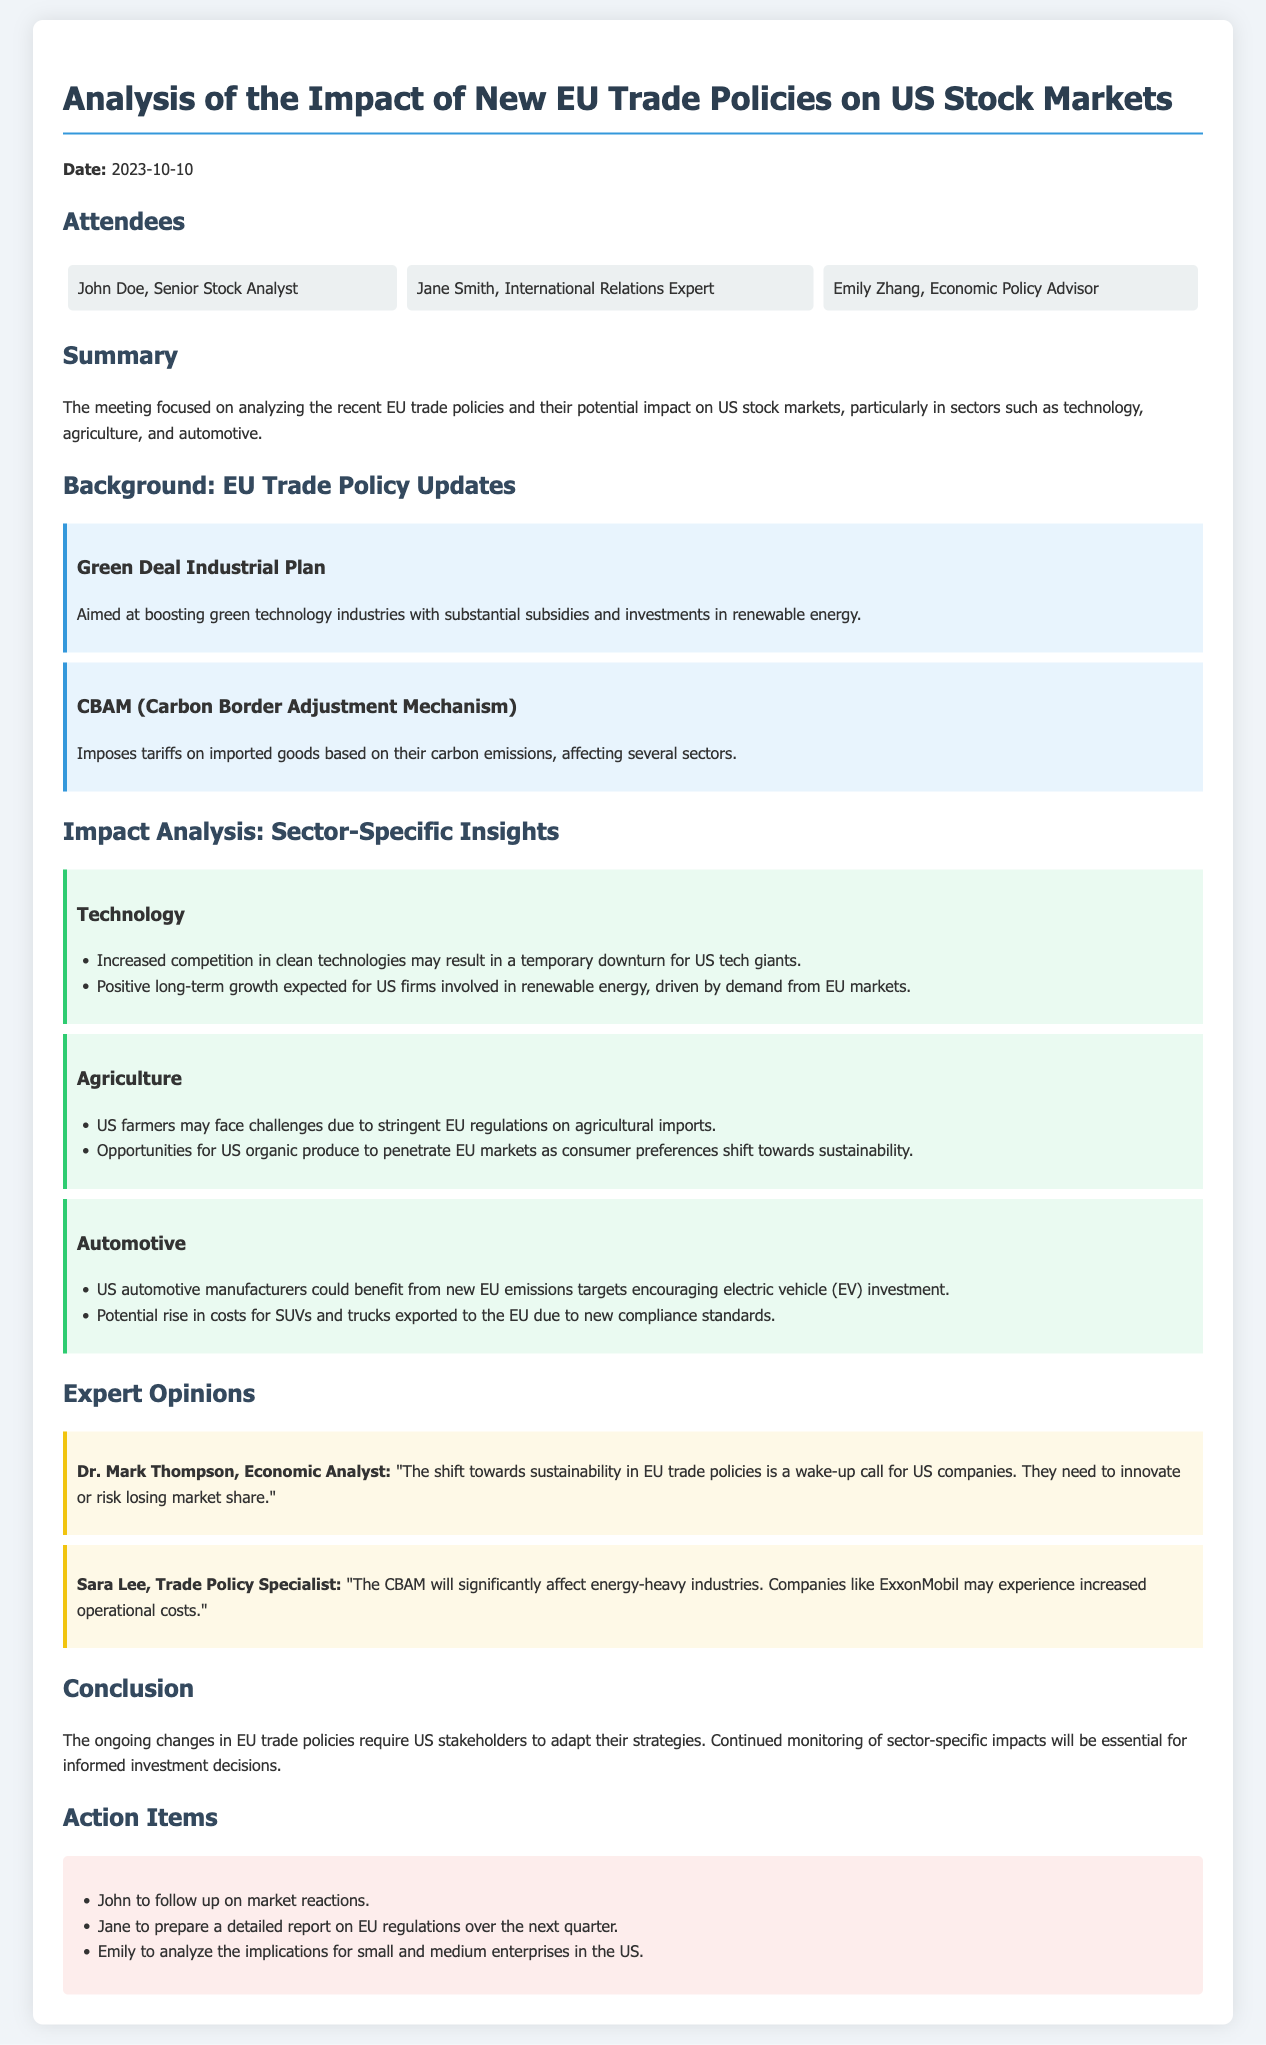What was the date of the meeting? The date of the meeting is mentioned at the beginning of the document.
Answer: 2023-10-10 Who is the Economic Policy Advisor present at the meeting? The document lists attendees, including their titles.
Answer: Emily Zhang What is the focus of the meeting? The summary section outlines the main focus of the meeting.
Answer: Analyzing the recent EU trade policies What are the two major EU trade policies discussed? The background section specifies the trade policies that are analyzed.
Answer: Green Deal Industrial Plan and CBAM Which sector may face challenges due to EU regulations on agricultural imports? The agriculture sector section discusses potential challenges.
Answer: US farmers What is the expected impact of EU emissions targets on the automotive sector? The automotive sector section indicates potential benefits from new targets.
Answer: Benefit from new EU emissions targets Who stated that US companies need to innovate to maintain market share? The expert opinions section attributes this statement to a specific analyst.
Answer: Dr. Mark Thompson What action item is assigned to Jane? The action items section specifies tasks assigned to attendees.
Answer: Prepare a detailed report on EU regulations What is the potential consequence for companies like ExxonMobil? The expert opinion section mentions specific impacts due to policy changes.
Answer: Increased operational costs What theme emerges from the meeting conclusion? The conclusion summarizes the necessary adaptation due to policy changes.
Answer: Adapt strategies 